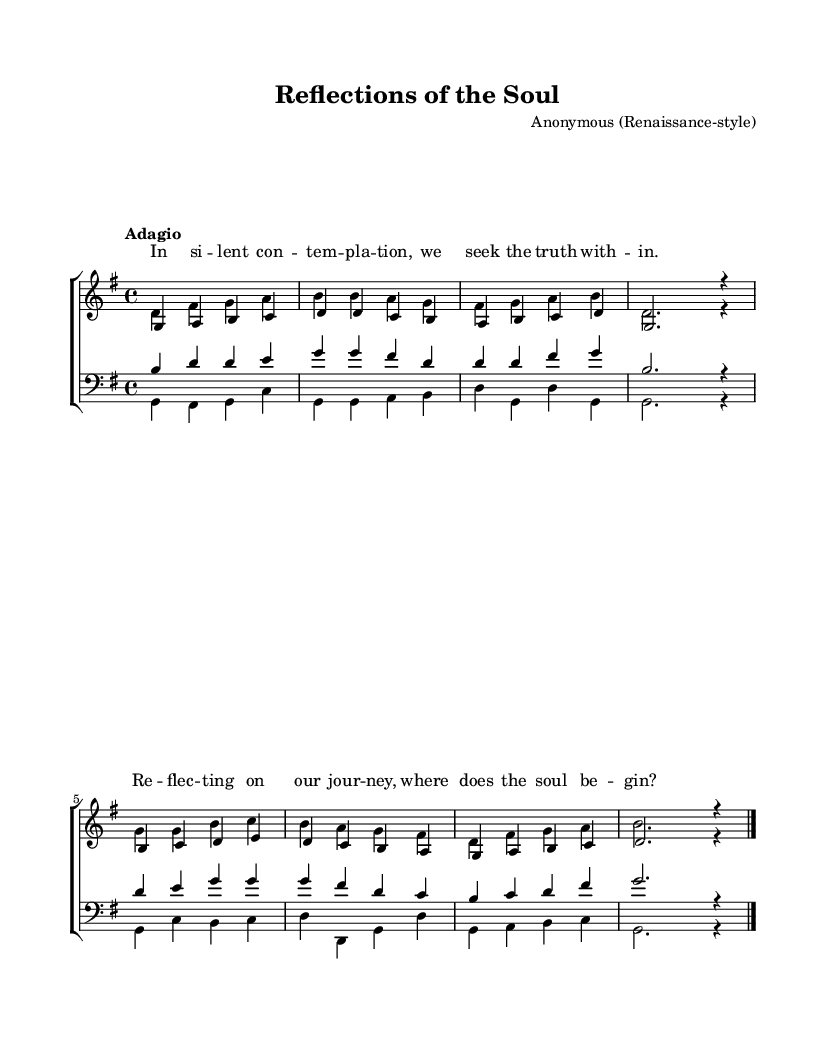What is the key signature of this music? The key signature is G major, which has one sharp (F#).
Answer: G major What is the time signature of the piece? The time signature is 4/4, indicating four beats per measure.
Answer: 4/4 What is the tempo marking of this piece? The tempo marking is "Adagio," which suggests a slow and leisurely pace.
Answer: Adagio How many voices are there in the soprano part? There are two voices in the soprano part: sopranos and altos.
Answer: Two Which section features the lyric "In silent contemplation"? The lyrics appear aligned above the soprano staff, specifically the sopranos' notes.
Answer: Soprano Identify the last note of the bass part. The last note of the bass part is G, written in a whole note at the end of the score.
Answer: G What is the primary musical texture of this piece? The primary musical texture is homophonic, where the voices move together harmonically.
Answer: Homophonic 